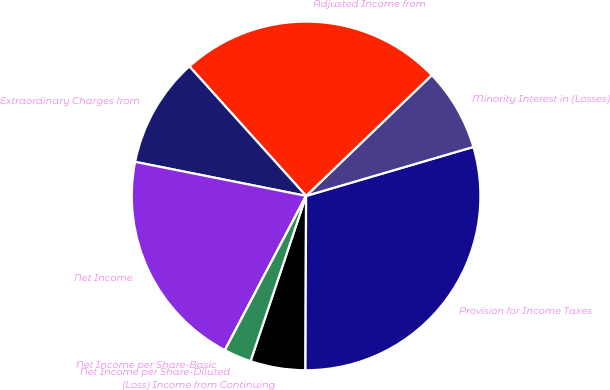Convert chart to OTSL. <chart><loc_0><loc_0><loc_500><loc_500><pie_chart><fcel>(Loss) Income from Continuing<fcel>Provision for Income Taxes<fcel>Minority Interest in (Losses)<fcel>Adjusted Income from<fcel>Extraordinary Charges from<fcel>Net Income<fcel>Net Income per Share-Basic<fcel>Net Income per Share-Diluted<nl><fcel>5.1%<fcel>29.59%<fcel>7.65%<fcel>24.49%<fcel>10.2%<fcel>20.42%<fcel>0.0%<fcel>2.55%<nl></chart> 